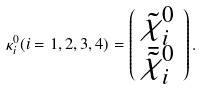Convert formula to latex. <formula><loc_0><loc_0><loc_500><loc_500>\kappa _ { i } ^ { 0 } ( i = 1 , 2 , 3 , 4 ) = \left ( \begin{array} { c } { { \tilde { \chi } _ { i } ^ { 0 } } } \\ { { \bar { \tilde { \chi } } _ { i } ^ { 0 } } } \end{array} \right ) .</formula> 